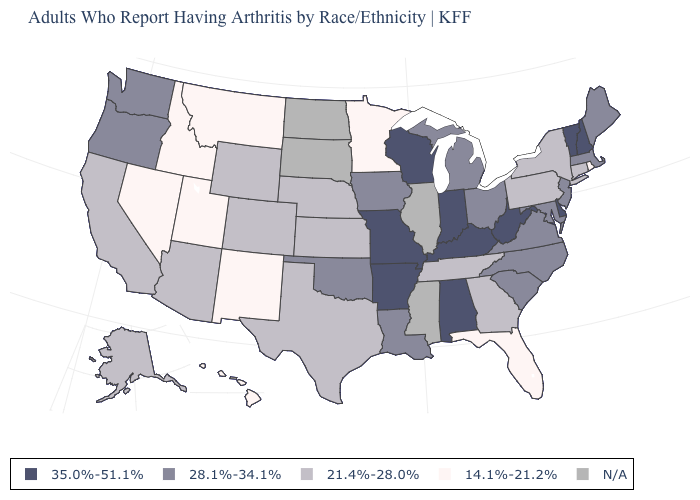Does Michigan have the lowest value in the USA?
Answer briefly. No. What is the value of Pennsylvania?
Answer briefly. 21.4%-28.0%. How many symbols are there in the legend?
Concise answer only. 5. What is the value of Montana?
Give a very brief answer. 14.1%-21.2%. Does Oklahoma have the lowest value in the USA?
Short answer required. No. What is the highest value in the USA?
Keep it brief. 35.0%-51.1%. Which states have the lowest value in the USA?
Be succinct. Florida, Hawaii, Idaho, Minnesota, Montana, Nevada, New Mexico, Rhode Island, Utah. Which states have the highest value in the USA?
Quick response, please. Alabama, Arkansas, Delaware, Indiana, Kentucky, Missouri, New Hampshire, Vermont, West Virginia, Wisconsin. Which states hav the highest value in the South?
Write a very short answer. Alabama, Arkansas, Delaware, Kentucky, West Virginia. What is the value of Missouri?
Be succinct. 35.0%-51.1%. What is the value of Tennessee?
Write a very short answer. 21.4%-28.0%. Name the states that have a value in the range 35.0%-51.1%?
Short answer required. Alabama, Arkansas, Delaware, Indiana, Kentucky, Missouri, New Hampshire, Vermont, West Virginia, Wisconsin. What is the highest value in the USA?
Quick response, please. 35.0%-51.1%. Name the states that have a value in the range 35.0%-51.1%?
Give a very brief answer. Alabama, Arkansas, Delaware, Indiana, Kentucky, Missouri, New Hampshire, Vermont, West Virginia, Wisconsin. How many symbols are there in the legend?
Answer briefly. 5. 